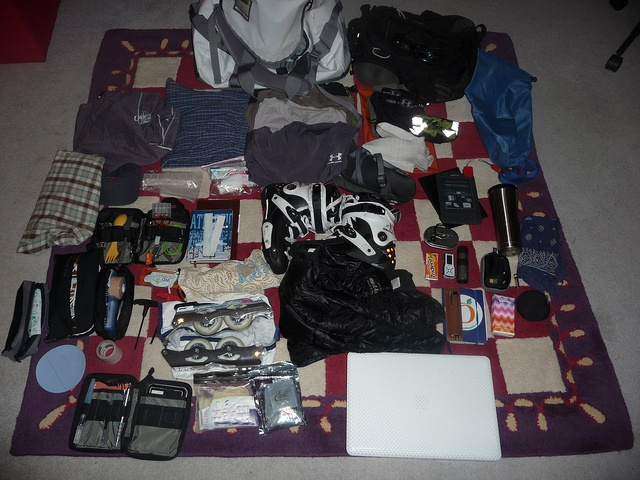Describe the objects in this image and their specific colors. I can see backpack in black and gray tones, backpack in black, darkgray, gray, and lightgray tones, suitcase in black, gray, navy, and darkgray tones, backpack in black, gray, and maroon tones, and book in black, darkgray, navy, gray, and blue tones in this image. 